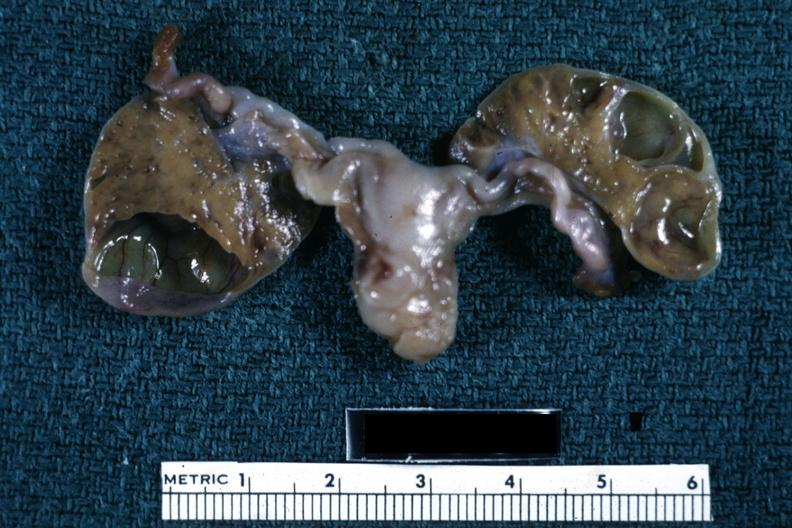what is present?
Answer the question using a single word or phrase. Theca luteum cysts in newborn 